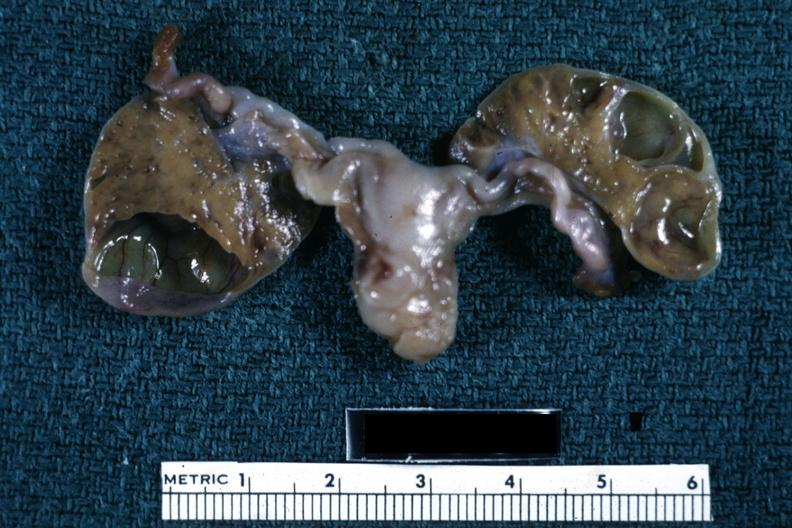what is present?
Answer the question using a single word or phrase. Theca luteum cysts in newborn 